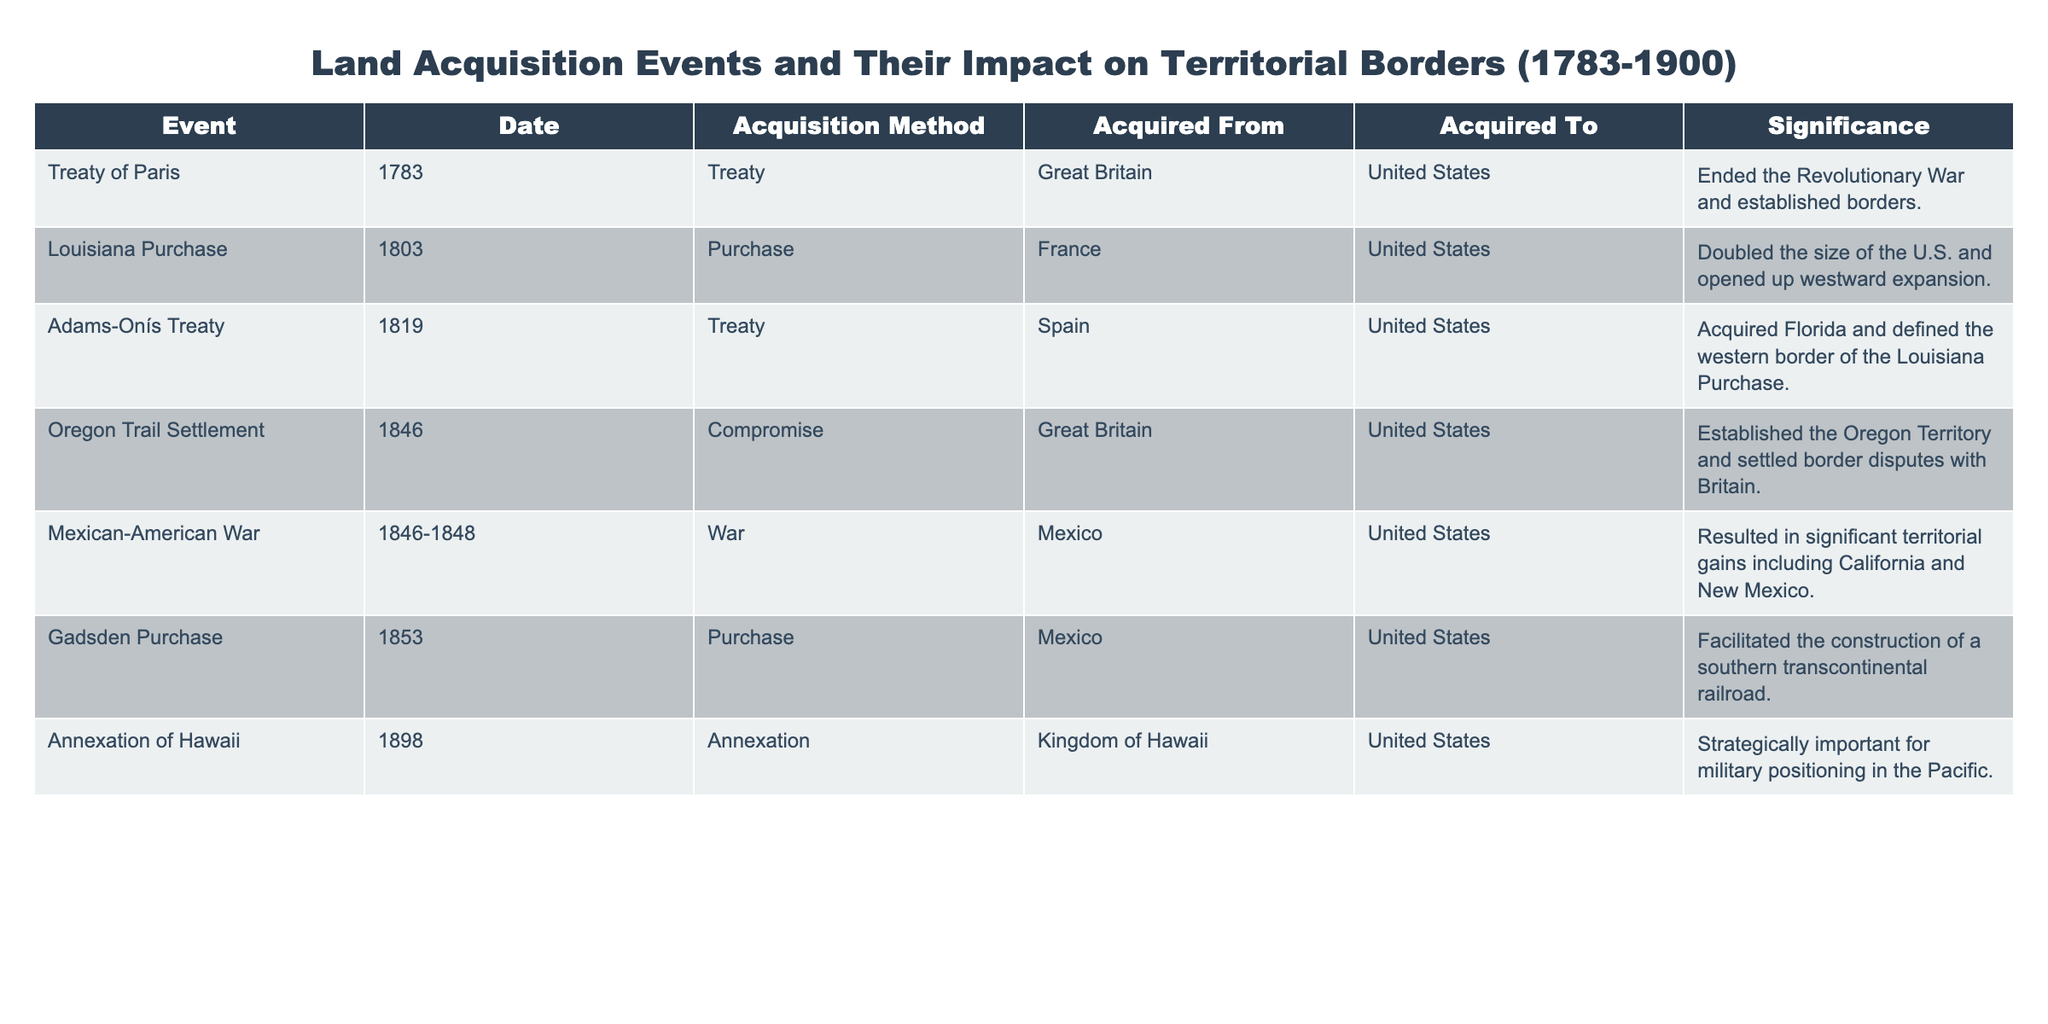What event ended the Revolutionary War? According to the table, the Treaty of Paris is listed as the event that occurred in 1783 and ended the Revolutionary War.
Answer: Treaty of Paris Which acquisition method was used for the Louisiana Purchase? The table indicates that the Louisiana Purchase was made through a purchase method in 1803.
Answer: Purchase How many total events are listed in the table? By counting the rows of the table, there are a total of 7 distinct events listed.
Answer: 7 Did the Mexican-American War result in territorial gains? The table shows that the Mexican-American War resulted in significant territorial gains, including California and New Mexico, which confirms the statement.
Answer: Yes What two territories were acquired through the Adams-Onís Treaty? The table states that the Adams-Onís Treaty acquired Florida and defined the western border of the Louisiana Purchase, indicating that those are the territories acquired.
Answer: Florida and western border of the Louisiana Purchase Which acquisition created the Oregon Territory? The table specifies that the Oregon Trail Settlement, a compromise in 1846, established the Oregon Territory, thus indicating its creation.
Answer: Oregon Trail Settlement Compare the significance of the Gadsden Purchase and the Annexation of Hawaii. The Gadsden Purchase facilitated the construction of a southern transcontinental railroad, while the Annexation of Hawaii was strategically important for military positioning in the Pacific, showing these events served different purposes.
Answer: Different purposes in expansion and military strategy What was the primary impact of the Louisiana Purchase? The table highlights that the primary impact of the Louisiana Purchase was that it doubled the size of the U.S. and opened up westward expansion.
Answer: Doubled U.S. size and opened westward expansion List the countries the United States acquired land from during the events listed. By examining the table, the countries acquired from include Great Britain, France, Spain, and Mexico.
Answer: Great Britain, France, Spain, Mexico Which event had the earliest date? Looking at the dates in the table, the earliest date is 1783, corresponding to the Treaty of Paris, which is the earliest event listed.
Answer: Treaty of Paris 